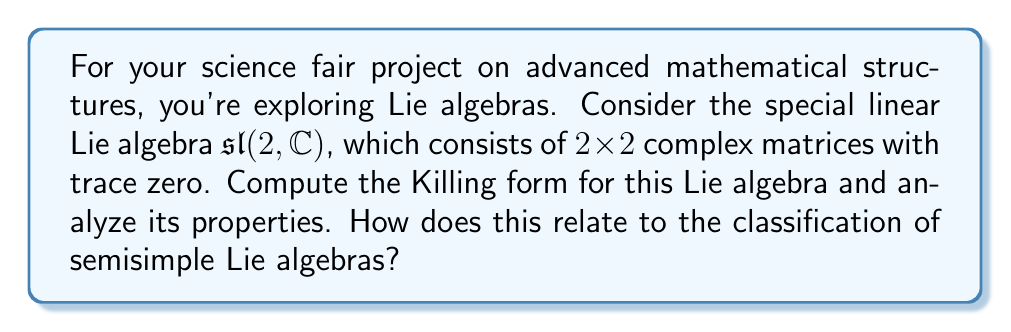Could you help me with this problem? Let's approach this step-by-step:

1) The Lie algebra $\mathfrak{sl}(2, \mathbb{C})$ has a basis consisting of three matrices:

   $$H = \begin{pmatrix} 1 & 0 \\ 0 & -1 \end{pmatrix}, \quad E = \begin{pmatrix} 0 & 1 \\ 0 & 0 \end{pmatrix}, \quad F = \begin{pmatrix} 0 & 0 \\ 1 & 0 \end{pmatrix}$$

2) The Killing form $B(X,Y)$ for a Lie algebra is defined as:

   $$B(X,Y) = \text{tr}(\text{ad}(X) \circ \text{ad}(Y))$$

   where $\text{ad}(X)(Y) = [X,Y]$ is the adjoint representation.

3) We need to compute $[X,Y]$ for all pairs of basis elements:

   $$[H,E] = 2E, \quad [H,F] = -2F, \quad [E,F] = H$$

4) Now, let's compute the Killing form for each pair of basis elements:

   $$B(H,H) = \text{tr}(\text{ad}(H) \circ \text{ad}(H)) = 2^2 + (-2)^2 = 8$$
   $$B(E,E) = B(F,F) = 0$$
   $$B(H,E) = B(E,H) = B(H,F) = B(F,H) = 0$$
   $$B(E,F) = B(F,E) = \text{tr}(\text{ad}(E) \circ \text{ad}(F)) = 2$$

5) Therefore, the Killing form matrix with respect to the basis $\{H,E,F\}$ is:

   $$B = \begin{pmatrix} 8 & 0 & 0 \\ 0 & 0 & 2 \\ 0 & 2 & 0 \end{pmatrix}$$

6) Properties of this Killing form:
   - It is symmetric (as all Killing forms are).
   - It is non-degenerate (det(B) ≠ 0), which is a key property of semisimple Lie algebras.
   - It is indefinite, with signature (1,2).

7) The non-degeneracy of the Killing form is crucial in the classification of semisimple Lie algebras. Cartan's criterion states that a Lie algebra is semisimple if and only if its Killing form is non-degenerate. This result for $\mathfrak{sl}(2, \mathbb{C})$ confirms its status as the simplest non-abelian semisimple Lie algebra.
Answer: The Killing form for $\mathfrak{sl}(2, \mathbb{C})$ with respect to the basis $\{H,E,F\}$ is:

$$B = \begin{pmatrix} 8 & 0 & 0 \\ 0 & 0 & 2 \\ 0 & 2 & 0 \end{pmatrix}$$

It is symmetric, non-degenerate, and indefinite with signature (1,2). The non-degeneracy confirms that $\mathfrak{sl}(2, \mathbb{C})$ is semisimple, illustrating Cartan's criterion for semisimplicity. 